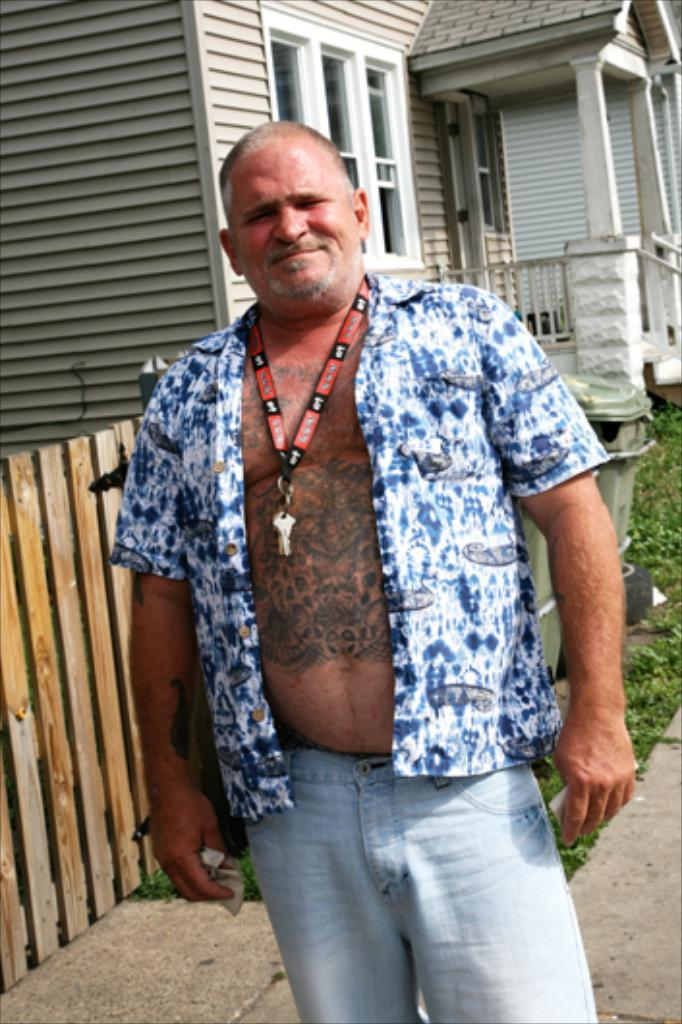Who is in the image? There is a person in the image. What is the person wearing on their upper body? The person is wearing a blue shirt. What type of clothing is the person wearing on their lower body? The person is wearing pants. What is the person's posture in the image? The person is standing. What can be seen in the background of the image? There is a house and plants in the background of the image. What type of cart is being used to transport the farm animals in the image? There is no cart or farm animals present in the image. 